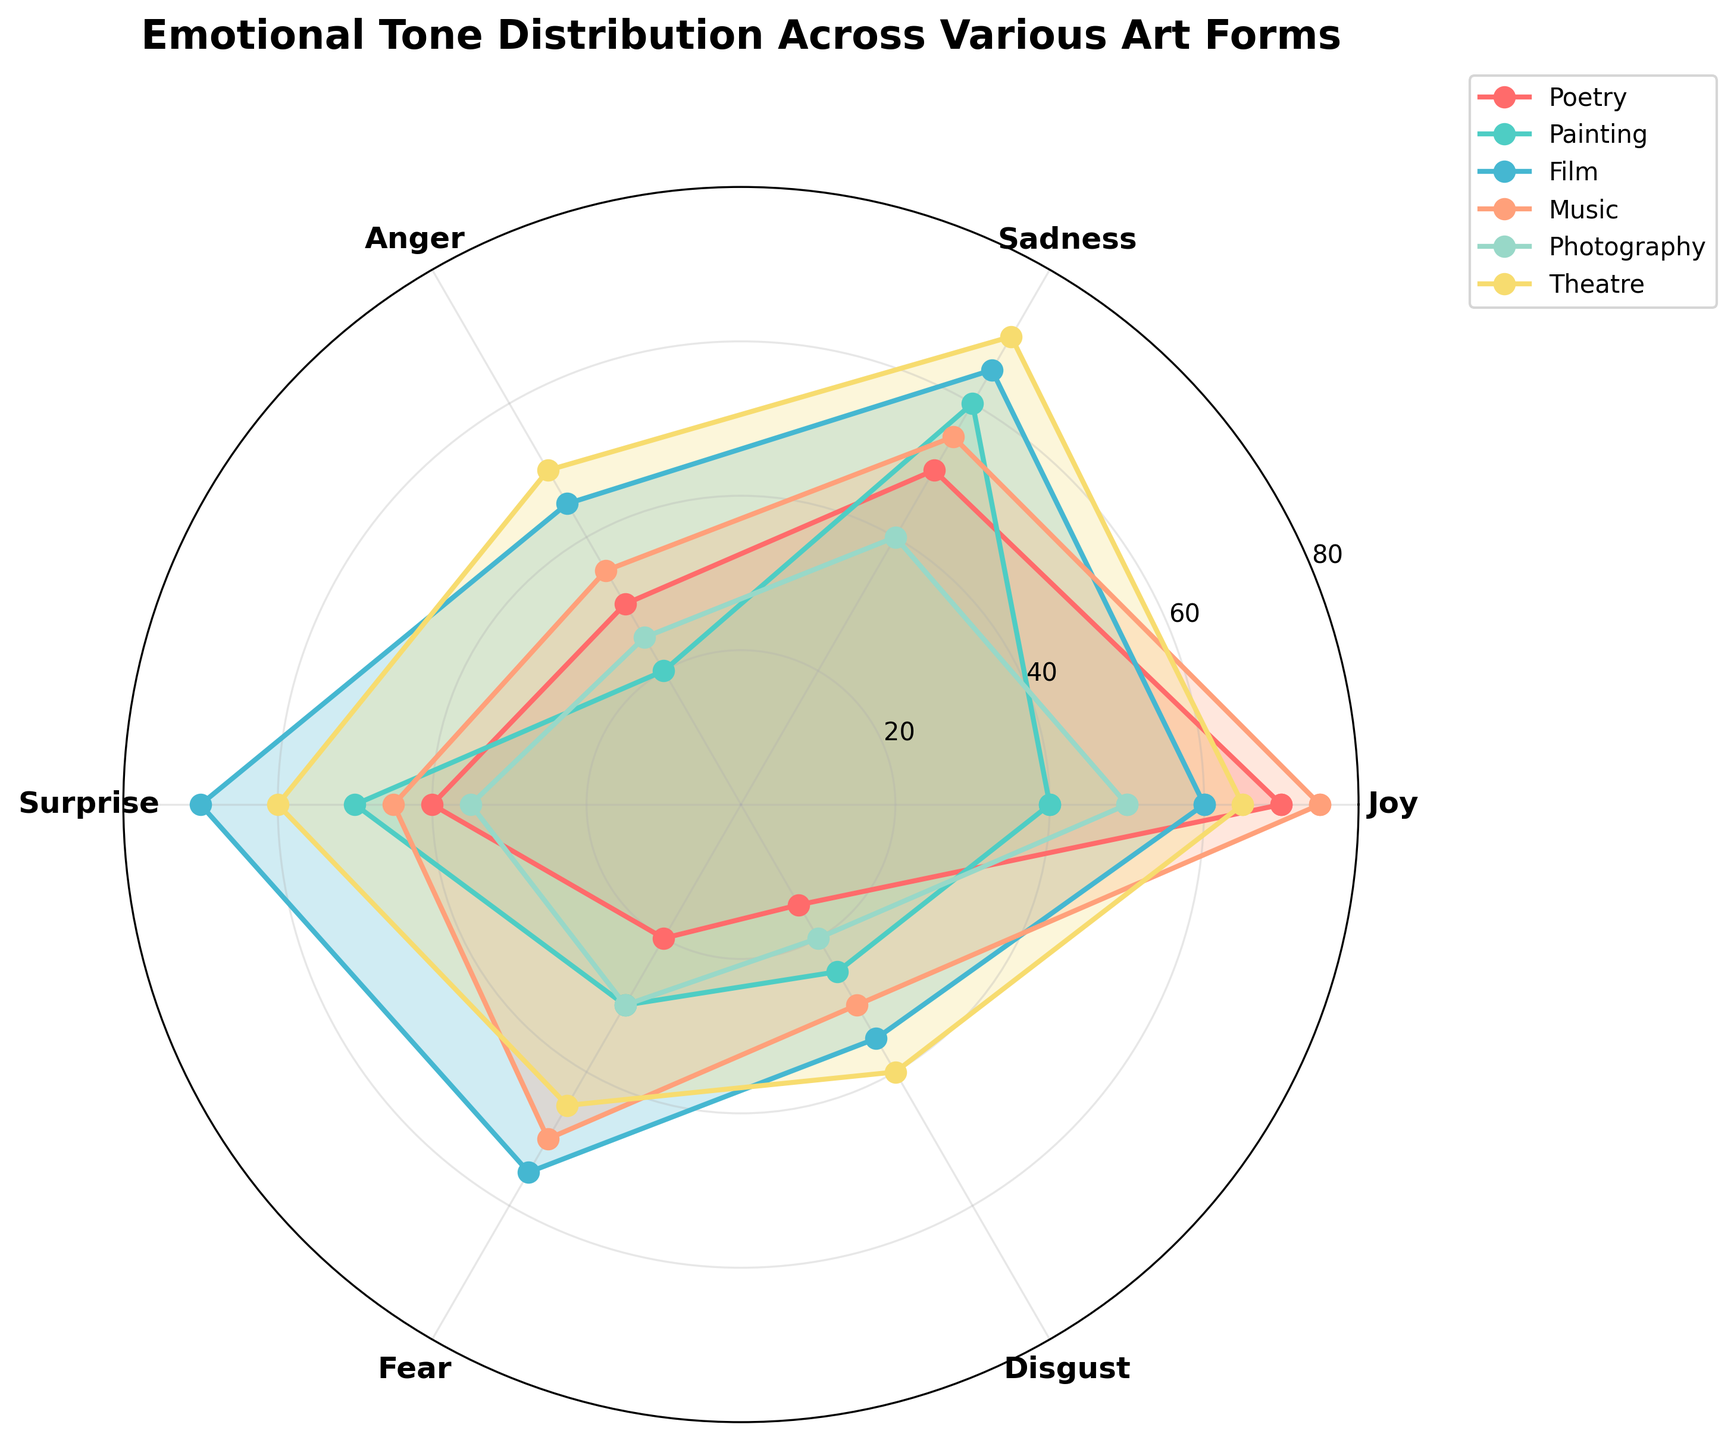What emotions are represented in the radar chart? The radar chart labels represent six emotions: Joy, Sadness, Anger, Surprise, Fear, and Disgust. We can see these labels positioned around the edges of the radar chart.
Answer: Joy, Sadness, Anger, Surprise, Fear, Disgust Which art form exhibits the highest level of Joy? By examining the radars, we observe that Music shows the highest point in the Joy dimension, reaching out to 75 on the radial axis.
Answer: Music What is the average level of Anger across all art forms? To find the average level of Anger, we sum the Anger values for all art forms (30+20+45+35+25+50 = 205) and divide by the number of art forms (6). The average is 205/6.
Answer: 34.17 Which art form shows the greatest disparity between Joy and Sadness? By visually comparing the differences between Joy and Sadness for each art form, we notice that Poetry shows a difference of 20 (70-50), Painting has a difference of 20 (40-60), Film has a difference of 5 (60-65), Music has a difference of 20 (75-55), Photography has a difference of 10 (50-40), and Theatre has a difference of 5 (65-70). Thus, Poetry, Painting, and Music exhibit the greatest disparity.
Answer: Poetry, Painting, Music Compare the levels of Fear in Painting and Theatre. Which one is greater? By looking at the radial position of Fear for both, we notice Painting has a Fear level of 30 and Theatre has 45.
Answer: Theatre What is the overall trend in Disgust across all art forms? Observing the extent of the Disgust values, we see they vary between 15 and 40. The order from least to greatest Disgust is Poetry (15), Photography (20), Painting (25), Music (30), Film (35), and Theatre (40). The trend gradually increases from Poetry to Theatre.
Answer: Increases from Poetry to Theatre Which art form has the closest levels for all emotions? By inspecting the radar chart, we note that Photography's values of Joy, Sadness, Anger, Surprise, Fear, and Disgust (50, 40, 25, 35, 30, 20) are the closest in range compared to the other art forms.
Answer: Photography How does the level of Surprise in Film compare to that in Music? The chart shows that Film has a higher Surprise level at 70 compared to Music's 45.
Answer: Film Looking at Poetry, which emotion is the least represented? Referencing Poetry's values, the least represented emotion is Disgust at 15.
Answer: Disgust Calculate the median level of Sadness for all the art forms. Ordering the Sadness values (40, 50, 55, 60, 65, 70) and finding the middle value for an even number of entries involves averaging the two central values: (60+55)/2.
Answer: 57.5 